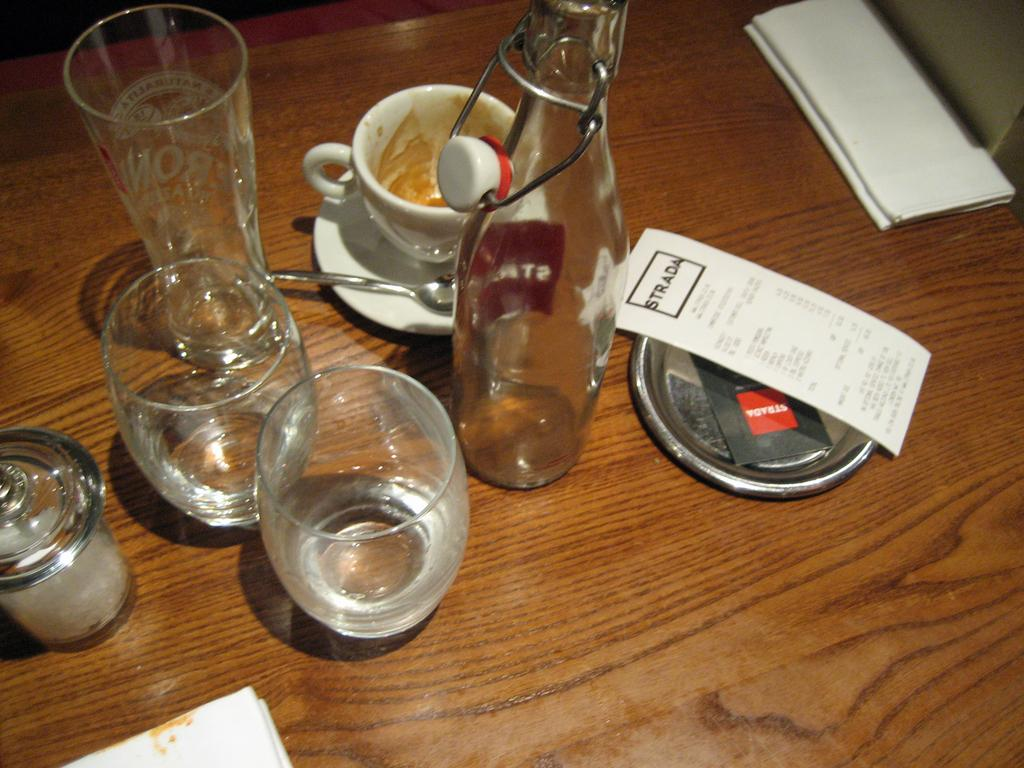What type of containers can be seen in the image? There are glasses, bottles, and a jar in the image. What is on top of the lid in the image? There is a paper on the lid. What is on the saucer in the image? The saucer has a cup and a spoon on it. What type of utensil is on the saucer? There is a spoon on the saucer. What type of sidewalk can be seen in the image? There is no sidewalk present in the image; it features containers, a lid, papers, and a saucer with a cup and spoon. 